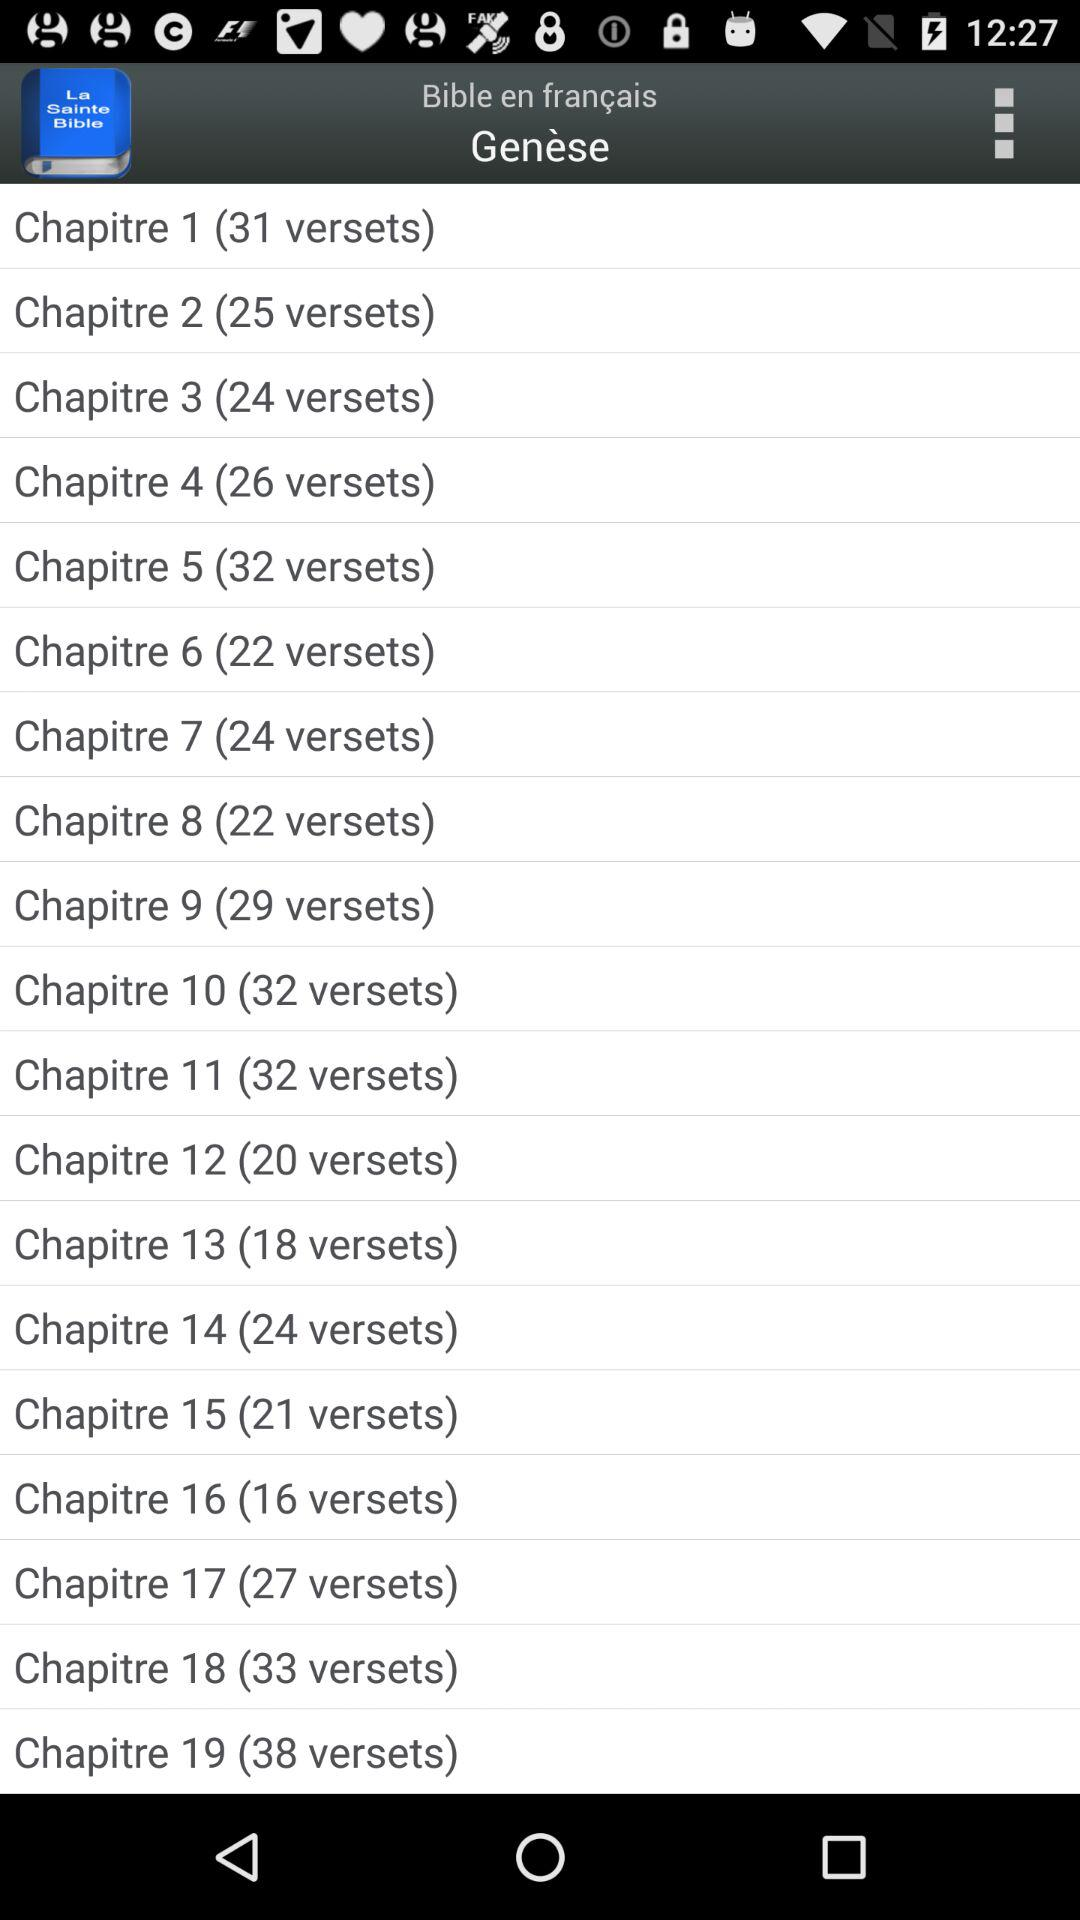How many verses are in the shortest chapter of Genesis?
Answer the question using a single word or phrase. 16 